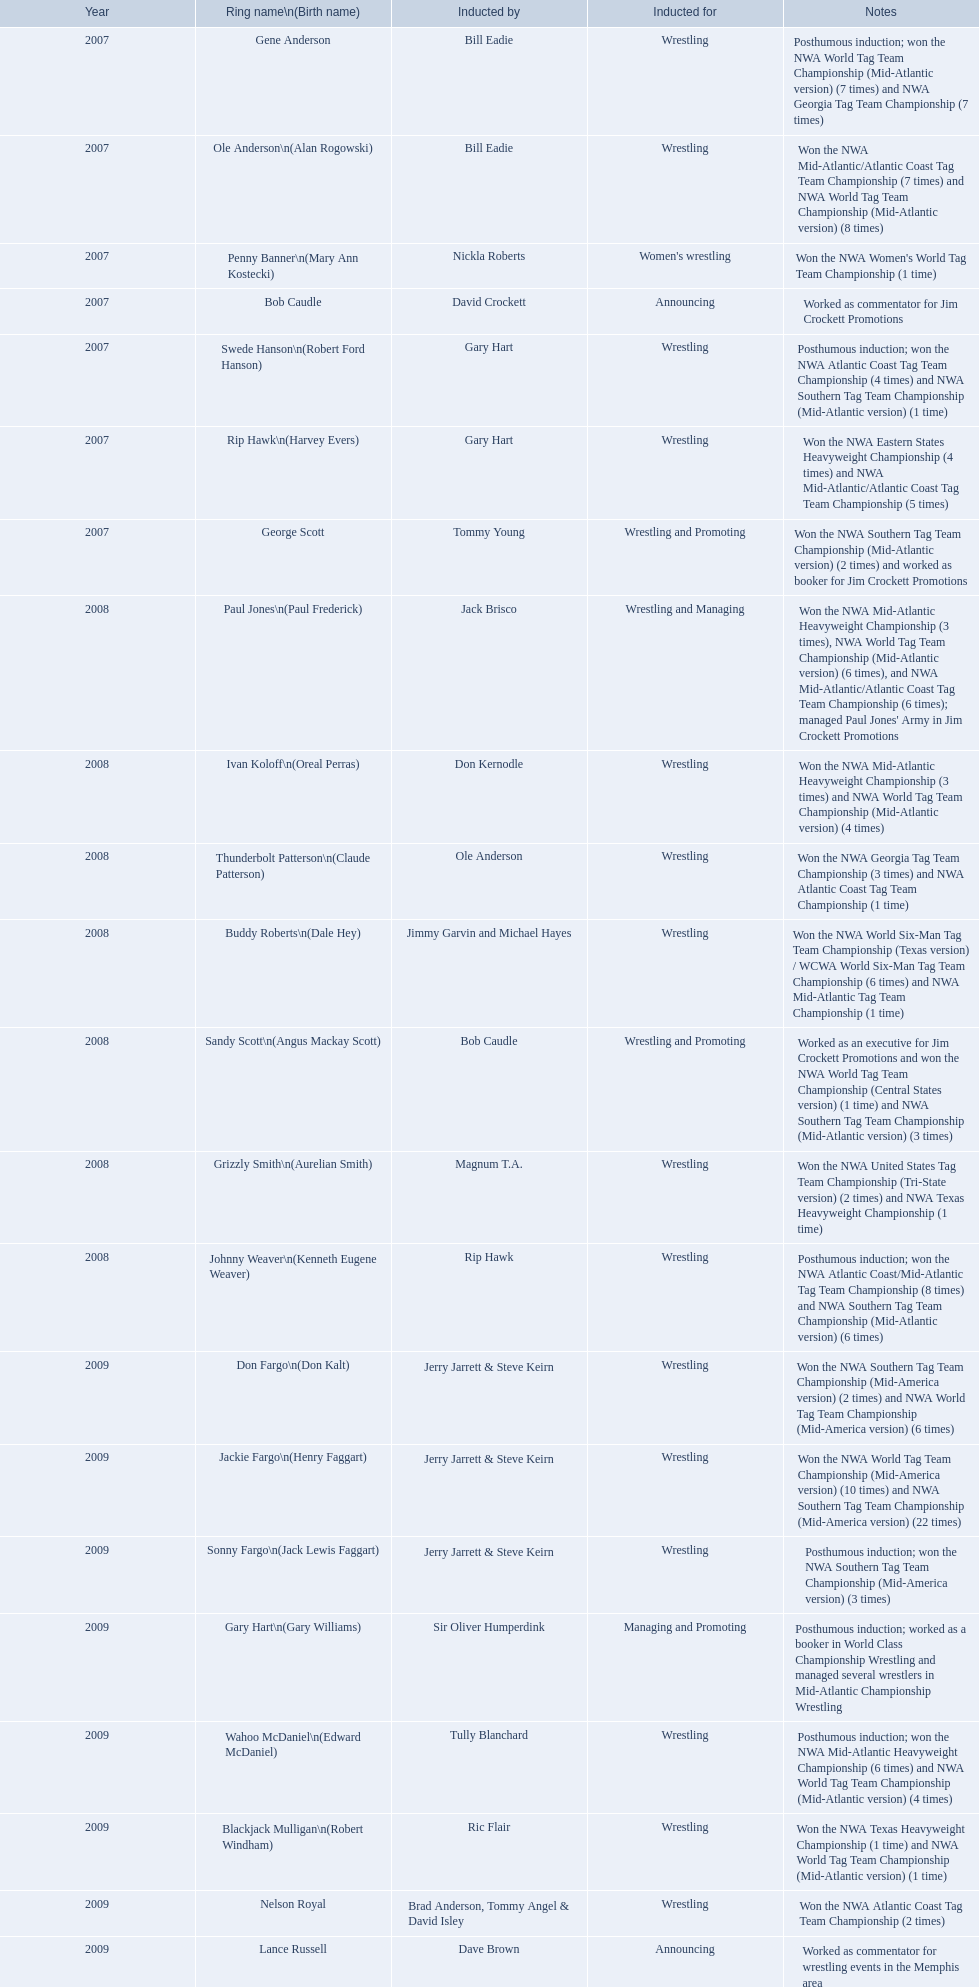What were all the wrestler's stage names? Gene Anderson, Ole Anderson\n(Alan Rogowski), Penny Banner\n(Mary Ann Kostecki), Bob Caudle, Swede Hanson\n(Robert Ford Hanson), Rip Hawk\n(Harvey Evers), George Scott, Paul Jones\n(Paul Frederick), Ivan Koloff\n(Oreal Perras), Thunderbolt Patterson\n(Claude Patterson), Buddy Roberts\n(Dale Hey), Sandy Scott\n(Angus Mackay Scott), Grizzly Smith\n(Aurelian Smith), Johnny Weaver\n(Kenneth Eugene Weaver), Don Fargo\n(Don Kalt), Jackie Fargo\n(Henry Faggart), Sonny Fargo\n(Jack Lewis Faggart), Gary Hart\n(Gary Williams), Wahoo McDaniel\n(Edward McDaniel), Blackjack Mulligan\n(Robert Windham), Nelson Royal, Lance Russell. Excluding bob caudle, who was a commentator? Lance Russell. Could you parse the entire table as a dict? {'header': ['Year', 'Ring name\\n(Birth name)', 'Inducted by', 'Inducted for', 'Notes'], 'rows': [['2007', 'Gene Anderson', 'Bill Eadie', 'Wrestling', 'Posthumous induction; won the NWA World Tag Team Championship (Mid-Atlantic version) (7 times) and NWA Georgia Tag Team Championship (7 times)'], ['2007', 'Ole Anderson\\n(Alan Rogowski)', 'Bill Eadie', 'Wrestling', 'Won the NWA Mid-Atlantic/Atlantic Coast Tag Team Championship (7 times) and NWA World Tag Team Championship (Mid-Atlantic version) (8 times)'], ['2007', 'Penny Banner\\n(Mary Ann Kostecki)', 'Nickla Roberts', "Women's wrestling", "Won the NWA Women's World Tag Team Championship (1 time)"], ['2007', 'Bob Caudle', 'David Crockett', 'Announcing', 'Worked as commentator for Jim Crockett Promotions'], ['2007', 'Swede Hanson\\n(Robert Ford Hanson)', 'Gary Hart', 'Wrestling', 'Posthumous induction; won the NWA Atlantic Coast Tag Team Championship (4 times) and NWA Southern Tag Team Championship (Mid-Atlantic version) (1 time)'], ['2007', 'Rip Hawk\\n(Harvey Evers)', 'Gary Hart', 'Wrestling', 'Won the NWA Eastern States Heavyweight Championship (4 times) and NWA Mid-Atlantic/Atlantic Coast Tag Team Championship (5 times)'], ['2007', 'George Scott', 'Tommy Young', 'Wrestling and Promoting', 'Won the NWA Southern Tag Team Championship (Mid-Atlantic version) (2 times) and worked as booker for Jim Crockett Promotions'], ['2008', 'Paul Jones\\n(Paul Frederick)', 'Jack Brisco', 'Wrestling and Managing', "Won the NWA Mid-Atlantic Heavyweight Championship (3 times), NWA World Tag Team Championship (Mid-Atlantic version) (6 times), and NWA Mid-Atlantic/Atlantic Coast Tag Team Championship (6 times); managed Paul Jones' Army in Jim Crockett Promotions"], ['2008', 'Ivan Koloff\\n(Oreal Perras)', 'Don Kernodle', 'Wrestling', 'Won the NWA Mid-Atlantic Heavyweight Championship (3 times) and NWA World Tag Team Championship (Mid-Atlantic version) (4 times)'], ['2008', 'Thunderbolt Patterson\\n(Claude Patterson)', 'Ole Anderson', 'Wrestling', 'Won the NWA Georgia Tag Team Championship (3 times) and NWA Atlantic Coast Tag Team Championship (1 time)'], ['2008', 'Buddy Roberts\\n(Dale Hey)', 'Jimmy Garvin and Michael Hayes', 'Wrestling', 'Won the NWA World Six-Man Tag Team Championship (Texas version) / WCWA World Six-Man Tag Team Championship (6 times) and NWA Mid-Atlantic Tag Team Championship (1 time)'], ['2008', 'Sandy Scott\\n(Angus Mackay Scott)', 'Bob Caudle', 'Wrestling and Promoting', 'Worked as an executive for Jim Crockett Promotions and won the NWA World Tag Team Championship (Central States version) (1 time) and NWA Southern Tag Team Championship (Mid-Atlantic version) (3 times)'], ['2008', 'Grizzly Smith\\n(Aurelian Smith)', 'Magnum T.A.', 'Wrestling', 'Won the NWA United States Tag Team Championship (Tri-State version) (2 times) and NWA Texas Heavyweight Championship (1 time)'], ['2008', 'Johnny Weaver\\n(Kenneth Eugene Weaver)', 'Rip Hawk', 'Wrestling', 'Posthumous induction; won the NWA Atlantic Coast/Mid-Atlantic Tag Team Championship (8 times) and NWA Southern Tag Team Championship (Mid-Atlantic version) (6 times)'], ['2009', 'Don Fargo\\n(Don Kalt)', 'Jerry Jarrett & Steve Keirn', 'Wrestling', 'Won the NWA Southern Tag Team Championship (Mid-America version) (2 times) and NWA World Tag Team Championship (Mid-America version) (6 times)'], ['2009', 'Jackie Fargo\\n(Henry Faggart)', 'Jerry Jarrett & Steve Keirn', 'Wrestling', 'Won the NWA World Tag Team Championship (Mid-America version) (10 times) and NWA Southern Tag Team Championship (Mid-America version) (22 times)'], ['2009', 'Sonny Fargo\\n(Jack Lewis Faggart)', 'Jerry Jarrett & Steve Keirn', 'Wrestling', 'Posthumous induction; won the NWA Southern Tag Team Championship (Mid-America version) (3 times)'], ['2009', 'Gary Hart\\n(Gary Williams)', 'Sir Oliver Humperdink', 'Managing and Promoting', 'Posthumous induction; worked as a booker in World Class Championship Wrestling and managed several wrestlers in Mid-Atlantic Championship Wrestling'], ['2009', 'Wahoo McDaniel\\n(Edward McDaniel)', 'Tully Blanchard', 'Wrestling', 'Posthumous induction; won the NWA Mid-Atlantic Heavyweight Championship (6 times) and NWA World Tag Team Championship (Mid-Atlantic version) (4 times)'], ['2009', 'Blackjack Mulligan\\n(Robert Windham)', 'Ric Flair', 'Wrestling', 'Won the NWA Texas Heavyweight Championship (1 time) and NWA World Tag Team Championship (Mid-Atlantic version) (1 time)'], ['2009', 'Nelson Royal', 'Brad Anderson, Tommy Angel & David Isley', 'Wrestling', 'Won the NWA Atlantic Coast Tag Team Championship (2 times)'], ['2009', 'Lance Russell', 'Dave Brown', 'Announcing', 'Worked as commentator for wrestling events in the Memphis area']]} 